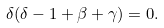<formula> <loc_0><loc_0><loc_500><loc_500>\delta ( \delta - 1 + \beta + \gamma ) = 0 .</formula> 